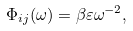Convert formula to latex. <formula><loc_0><loc_0><loc_500><loc_500>\Phi _ { i j } ( \omega ) = \beta \varepsilon \omega ^ { - 2 } ,</formula> 